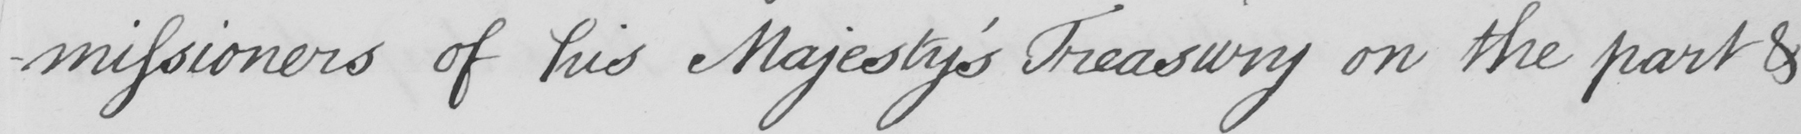What does this handwritten line say? -missioners of his Majesty ' s Treasury on the part & 